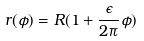<formula> <loc_0><loc_0><loc_500><loc_500>r ( \phi ) = R ( 1 + \frac { \epsilon } { 2 \pi } \phi )</formula> 